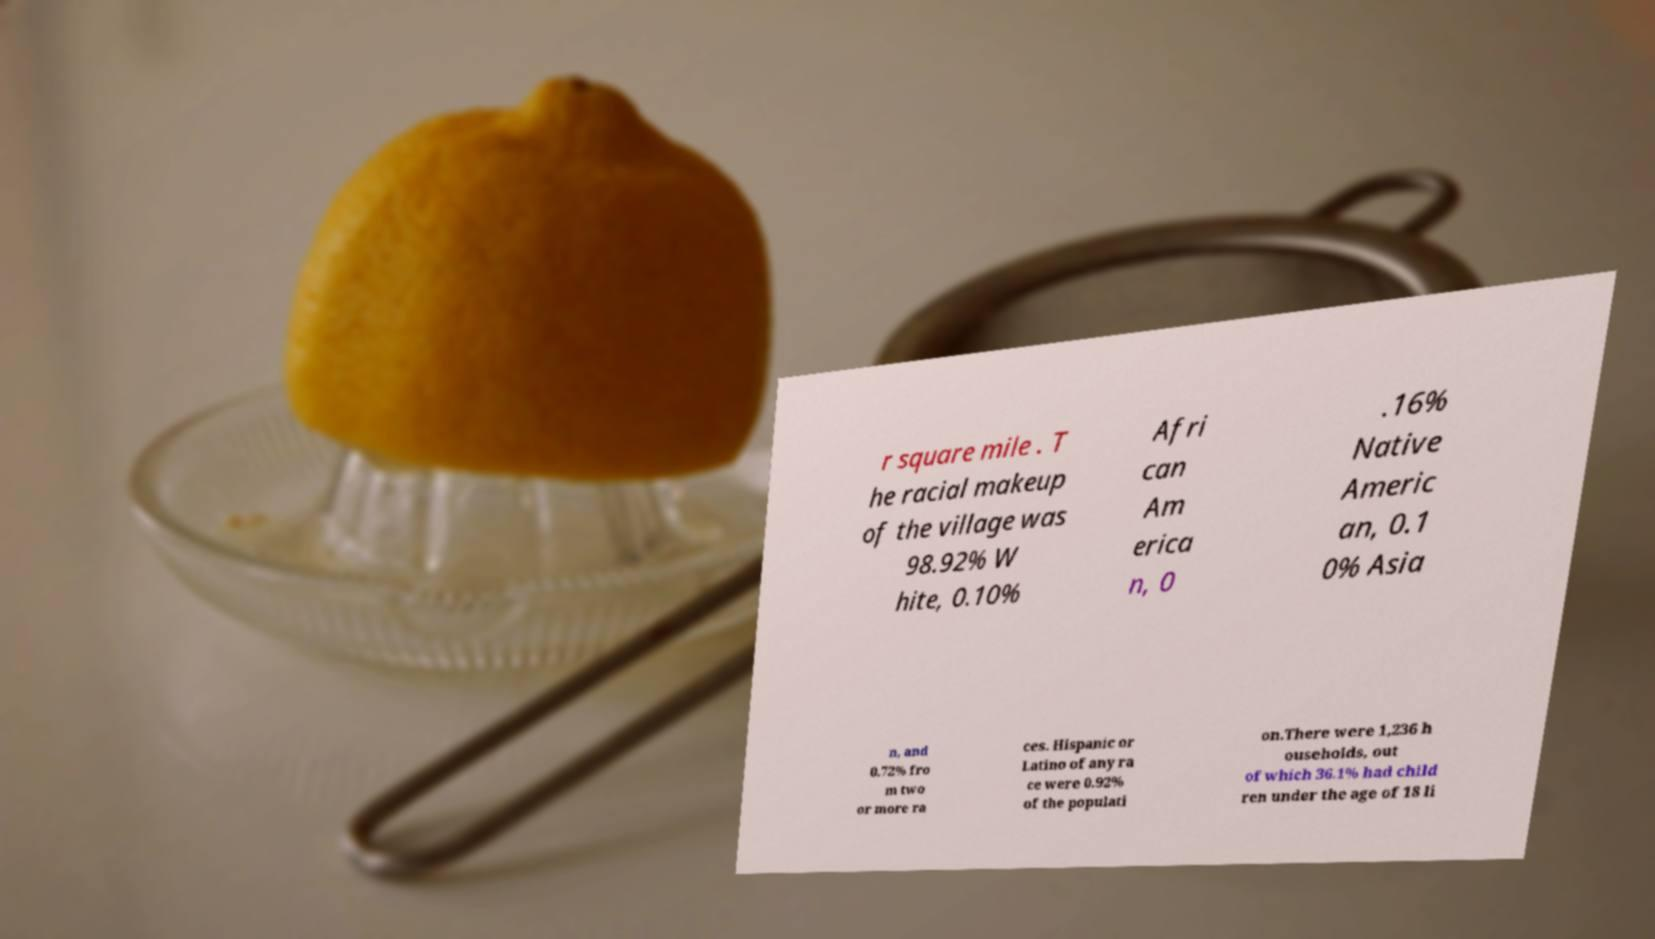I need the written content from this picture converted into text. Can you do that? r square mile . T he racial makeup of the village was 98.92% W hite, 0.10% Afri can Am erica n, 0 .16% Native Americ an, 0.1 0% Asia n, and 0.72% fro m two or more ra ces. Hispanic or Latino of any ra ce were 0.92% of the populati on.There were 1,236 h ouseholds, out of which 36.1% had child ren under the age of 18 li 